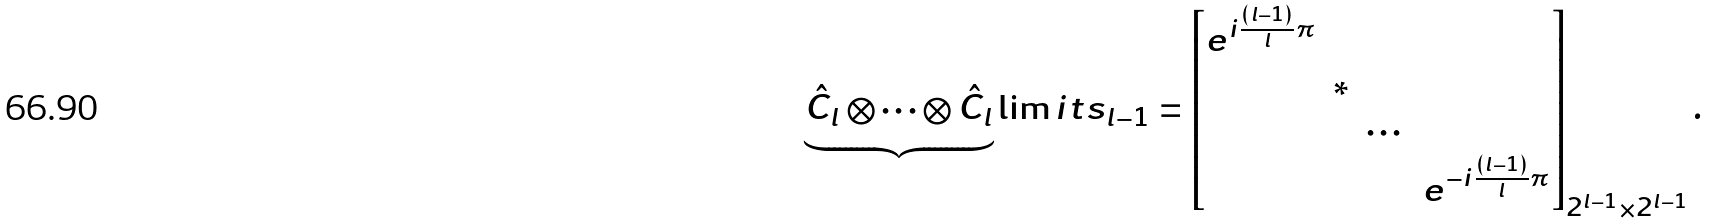Convert formula to latex. <formula><loc_0><loc_0><loc_500><loc_500>\underbrace { \hat { C } _ { l } \otimes \cdots \otimes \hat { C } _ { l } } \lim i t s _ { l - 1 } = \begin{bmatrix} e ^ { i \frac { ( l - 1 ) } { l } \pi } & & & \\ & * & & \\ & & \cdots & \\ & & & e ^ { - i \frac { ( l - 1 ) } { l } \pi } \end{bmatrix} _ { 2 ^ { l - 1 } \times 2 ^ { l - 1 } } .</formula> 